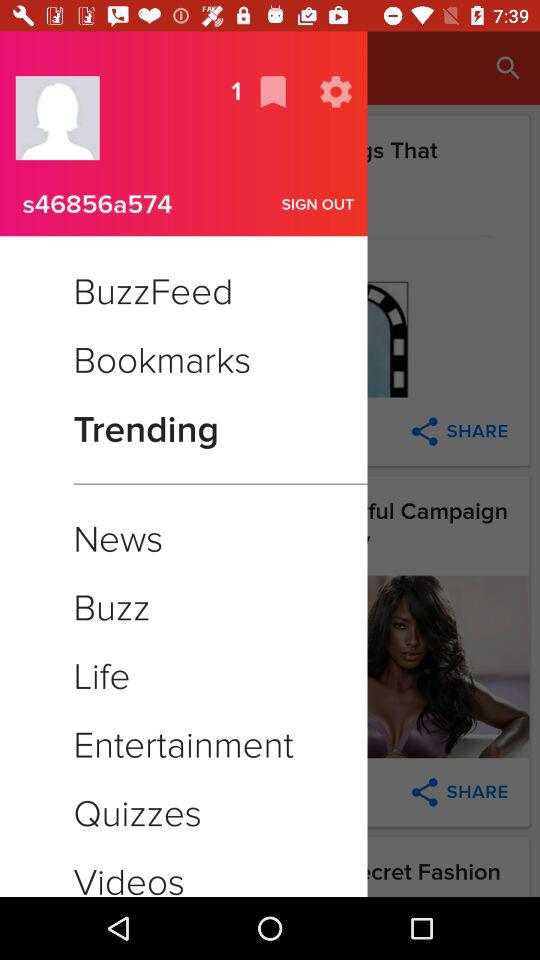What is the username? Te username is "s46856a574". 